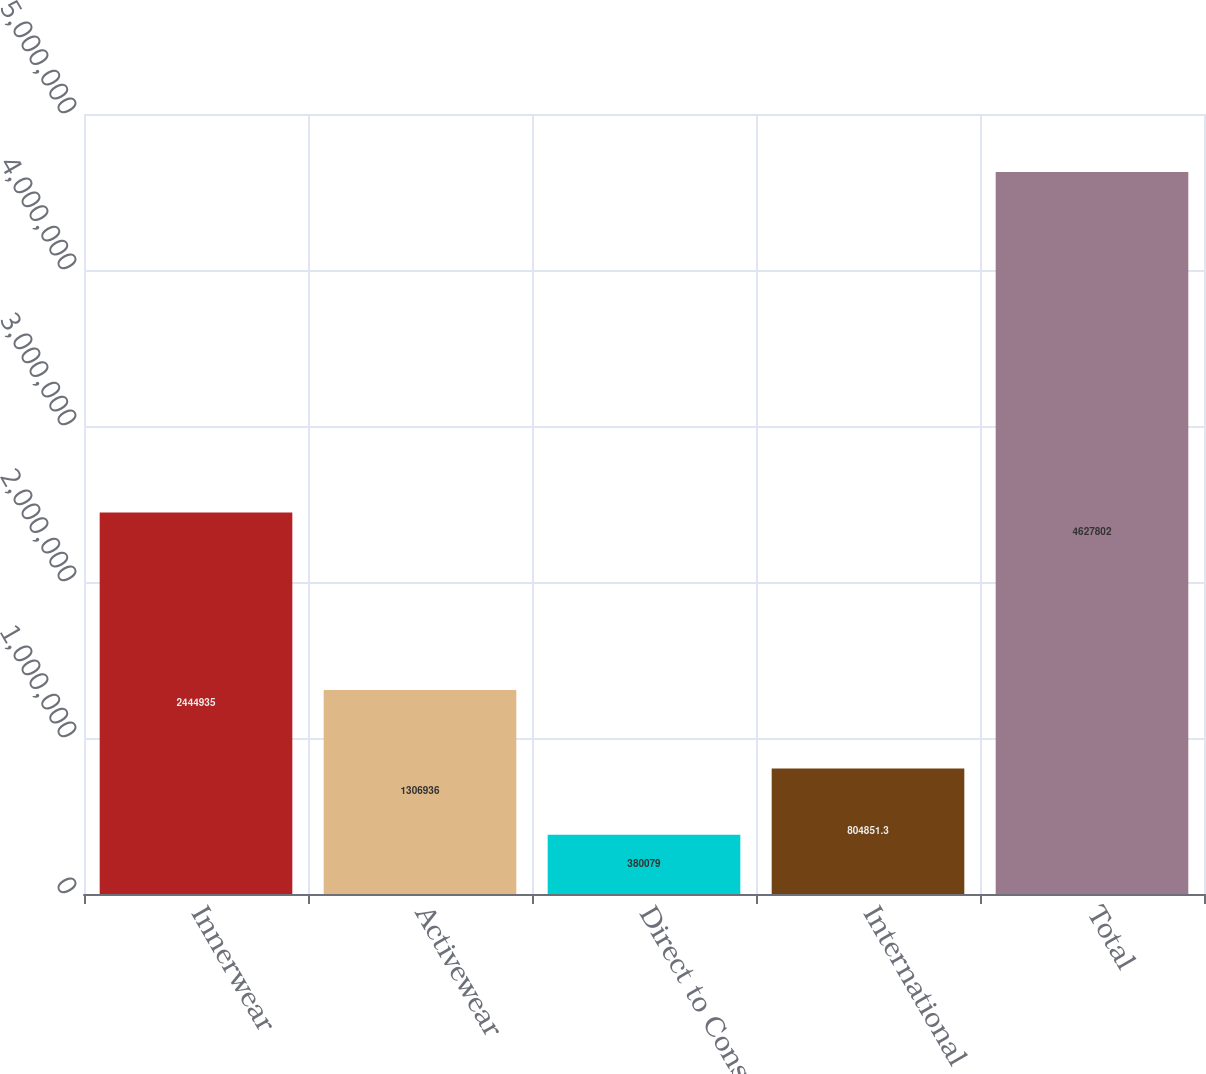<chart> <loc_0><loc_0><loc_500><loc_500><bar_chart><fcel>Innerwear<fcel>Activewear<fcel>Direct to Consumer<fcel>International<fcel>Total<nl><fcel>2.44494e+06<fcel>1.30694e+06<fcel>380079<fcel>804851<fcel>4.6278e+06<nl></chart> 